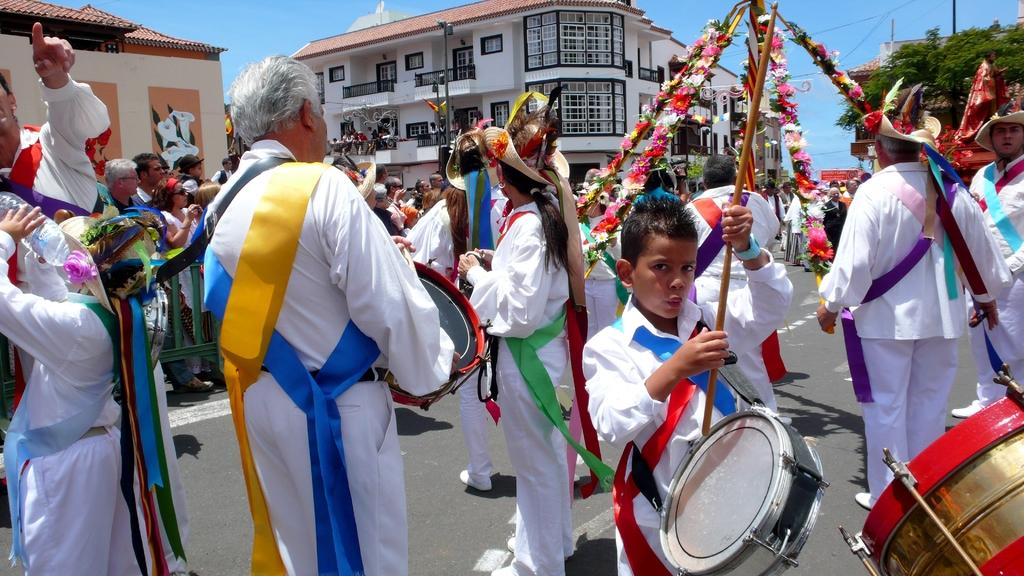What is happening in the image? There are people standing in the image. What can be seen in the background of the image? There is a building in the background of the image. How many eyes can be seen on the tooth in the image? There is no tooth present in the image, and therefore no eyes can be seen on it. 